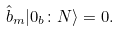Convert formula to latex. <formula><loc_0><loc_0><loc_500><loc_500>\hat { b } _ { m } | 0 _ { b } \colon N \rangle = 0 .</formula> 